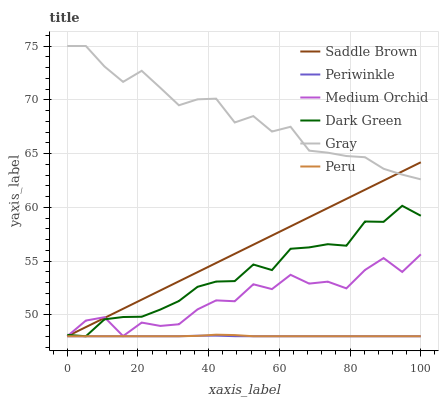Does Periwinkle have the minimum area under the curve?
Answer yes or no. Yes. Does Gray have the maximum area under the curve?
Answer yes or no. Yes. Does Medium Orchid have the minimum area under the curve?
Answer yes or no. No. Does Medium Orchid have the maximum area under the curve?
Answer yes or no. No. Is Saddle Brown the smoothest?
Answer yes or no. Yes. Is Medium Orchid the roughest?
Answer yes or no. Yes. Is Periwinkle the smoothest?
Answer yes or no. No. Is Periwinkle the roughest?
Answer yes or no. No. Does Medium Orchid have the lowest value?
Answer yes or no. Yes. Does Gray have the highest value?
Answer yes or no. Yes. Does Medium Orchid have the highest value?
Answer yes or no. No. Is Peru less than Gray?
Answer yes or no. Yes. Is Gray greater than Dark Green?
Answer yes or no. Yes. Does Dark Green intersect Medium Orchid?
Answer yes or no. Yes. Is Dark Green less than Medium Orchid?
Answer yes or no. No. Is Dark Green greater than Medium Orchid?
Answer yes or no. No. Does Peru intersect Gray?
Answer yes or no. No. 